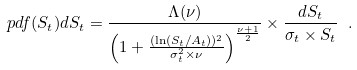Convert formula to latex. <formula><loc_0><loc_0><loc_500><loc_500>p d f ( S _ { t } ) d S _ { t } = \frac { \Lambda ( \nu ) } { \left ( 1 + \frac { ( \ln ( S _ { t } / A _ { t } ) ) ^ { 2 } } { \sigma _ { t } ^ { 2 } \times \nu } \right ) ^ { \frac { \nu + 1 } { 2 } } } \times \frac { d S _ { t } } { \sigma _ { t } \times S _ { t } } \ .</formula> 